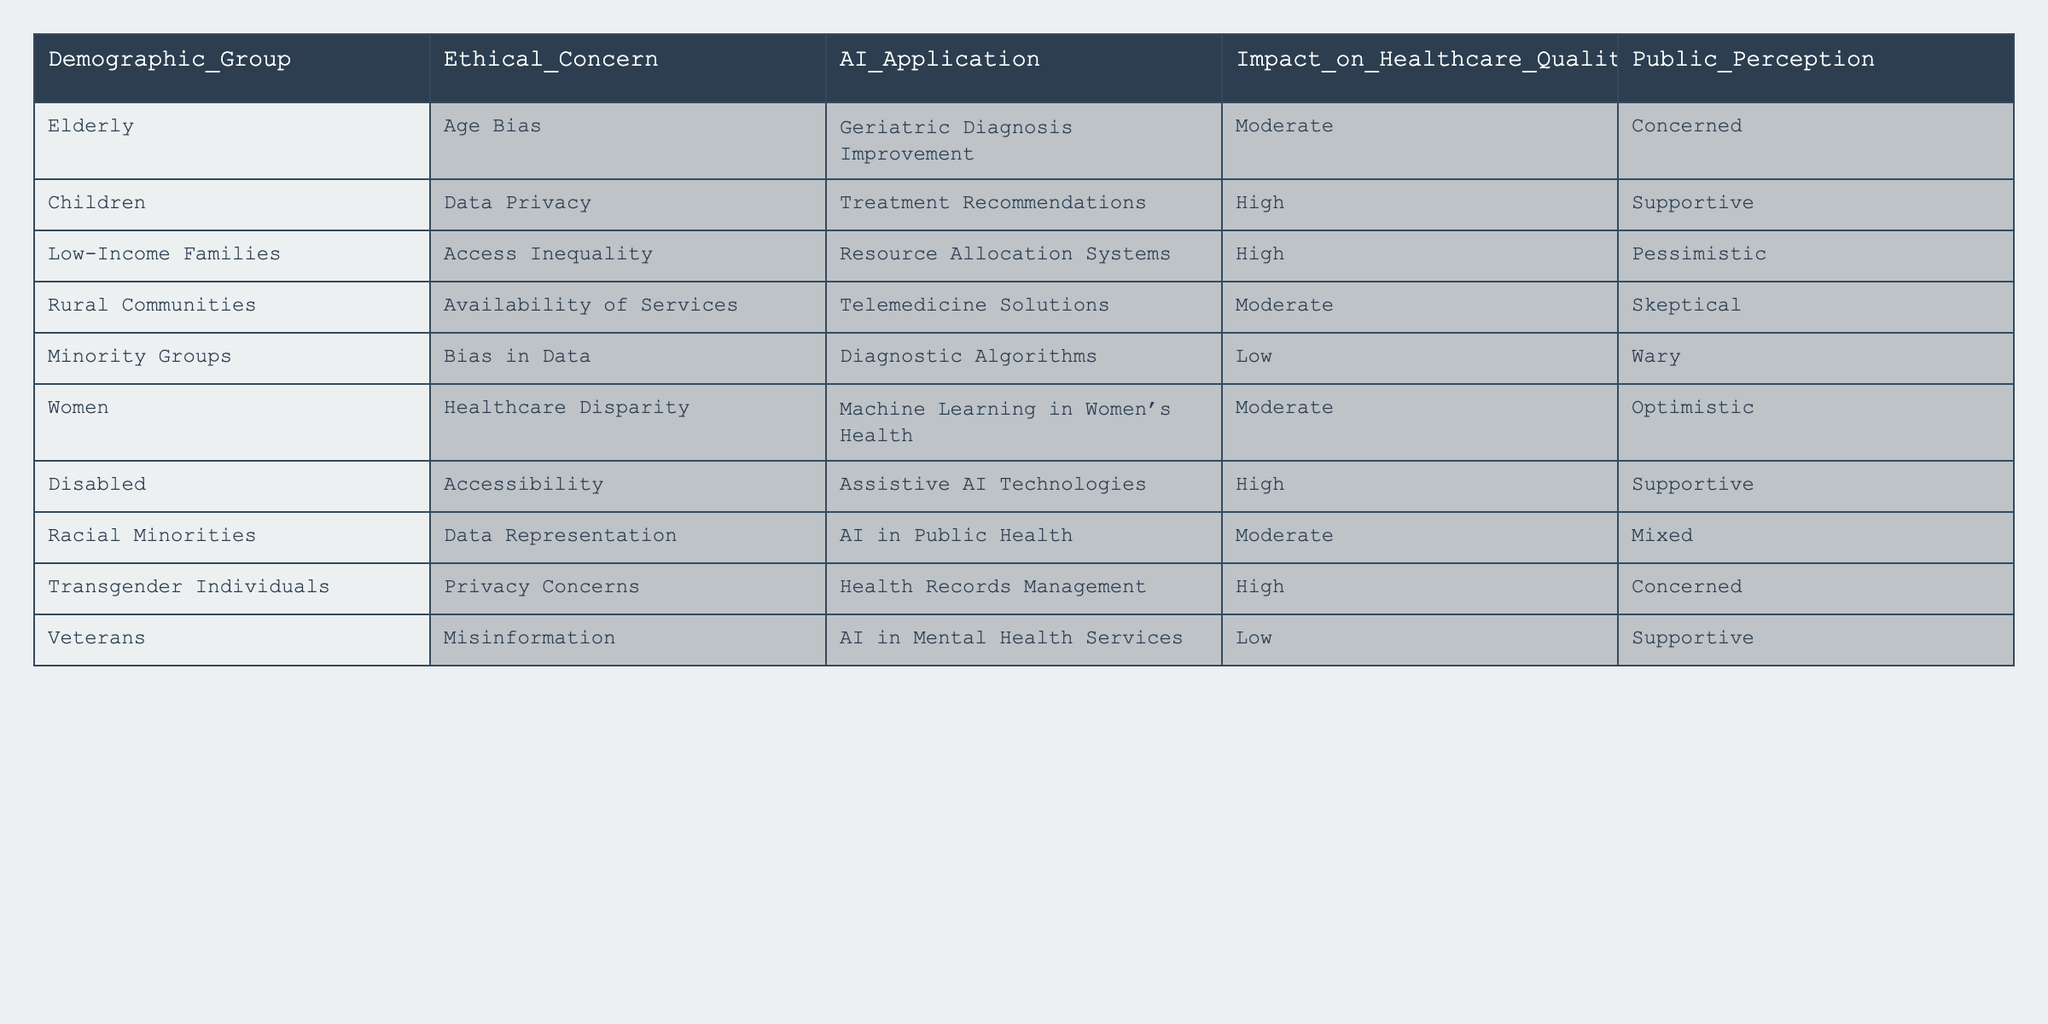What is the ethical concern associated with children in healthcare AI applications? The table indicates that the ethical concern for children is related to data privacy.
Answer: Data Privacy Which demographic group has the highest impact on healthcare quality according to the table? The demographic group with the highest impact is Low-Income Families, as their impact is classified as high.
Answer: Low-Income Families Are veterans considered concerned about the AI applications in mental health services? The data shows that veterans are supportive of AI applications in mental health services, which means they are not concerned.
Answer: No How does public perception of AI applications differ between children and disabled individuals? Children have a supportive public perception while disabled individuals are also supportive, indicating similarities.
Answer: Similar What is the average impact rating for the demographic groups listed? The impact ratings are: Moderate (3), High (4), Low (2). The sum is 3+4+2 = 9, and there are 7 groups, so the average is 9/7 ≈ 1.29, but it's important to note that these are categorical ratings not numeric values.
Answer: Not calculable Which demographic group exhibits wariness in relation to AI applications in healthcare? The table states that minority groups feel wary regarding AI applications.
Answer: Minority Groups Does the table indicate any demographic group that supports AI applications related to resource allocation systems? The table states that Low-Income Families hold a pessimistic view regarding AI applications in resource allocation systems, indicating a lack of support.
Answer: No What is the relationship between accessibility concerns and disabled individuals in the context of AI? The table shows that disabled individuals face accessibility concerns, and assistive AI technologies can significantly impact them, yielding a high impact rating.
Answer: High Impact Which demographic groups are classified under the ethical concern of bias in AI applications? The table lists minority groups specifically for bias in data, while the elderly have age bias, indicating multiple groups are concerned about bias.
Answer: Minority Groups, Elderly Is there a demographic group with a low impact rating that is concerned about AI healthcare applications? The table indicates that veterans have a low impact rating and are supportive of AI applications, not concerned.
Answer: No 